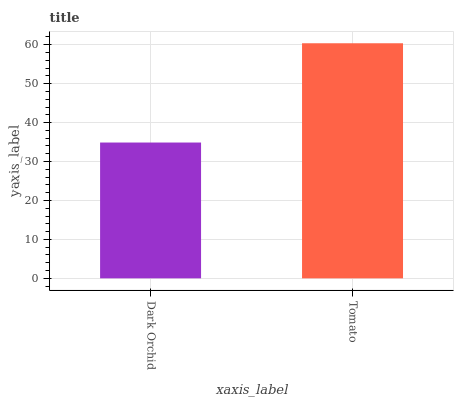Is Dark Orchid the minimum?
Answer yes or no. Yes. Is Tomato the maximum?
Answer yes or no. Yes. Is Tomato the minimum?
Answer yes or no. No. Is Tomato greater than Dark Orchid?
Answer yes or no. Yes. Is Dark Orchid less than Tomato?
Answer yes or no. Yes. Is Dark Orchid greater than Tomato?
Answer yes or no. No. Is Tomato less than Dark Orchid?
Answer yes or no. No. Is Tomato the high median?
Answer yes or no. Yes. Is Dark Orchid the low median?
Answer yes or no. Yes. Is Dark Orchid the high median?
Answer yes or no. No. Is Tomato the low median?
Answer yes or no. No. 